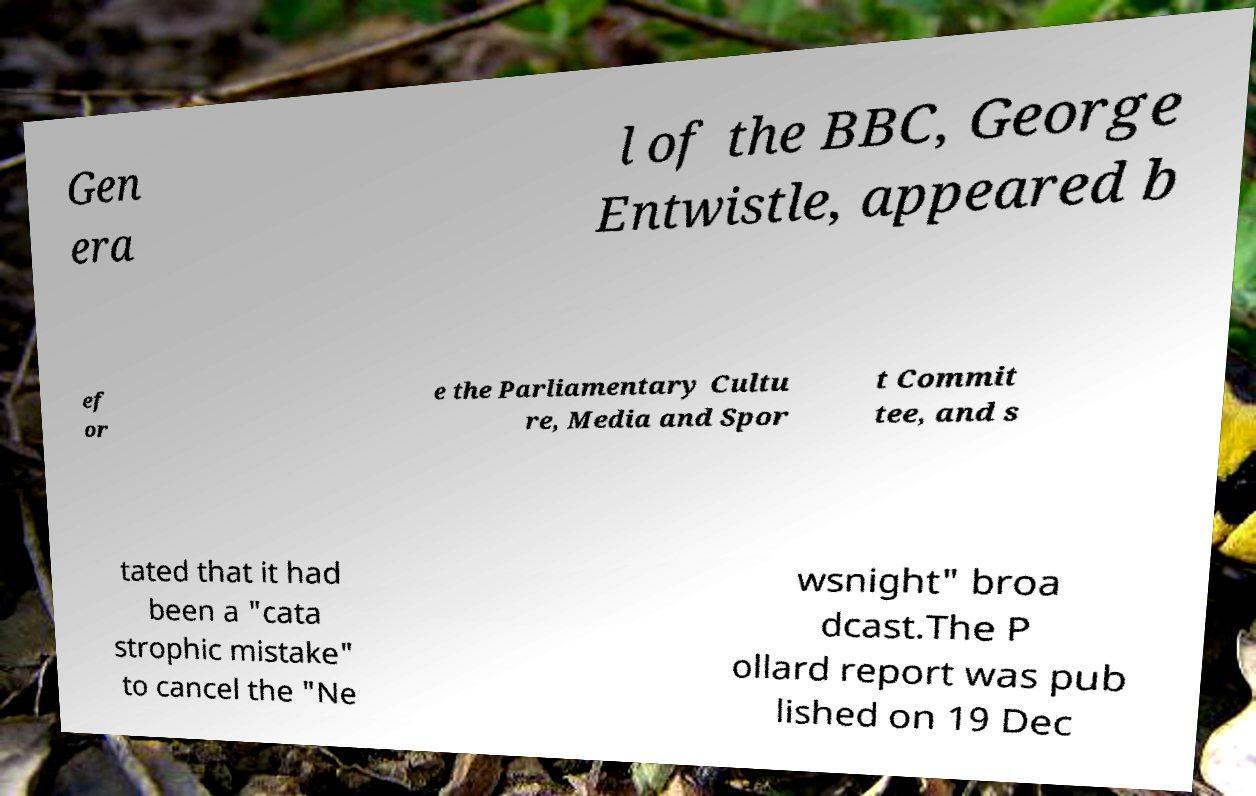Please identify and transcribe the text found in this image. Gen era l of the BBC, George Entwistle, appeared b ef or e the Parliamentary Cultu re, Media and Spor t Commit tee, and s tated that it had been a "cata strophic mistake" to cancel the "Ne wsnight" broa dcast.The P ollard report was pub lished on 19 Dec 